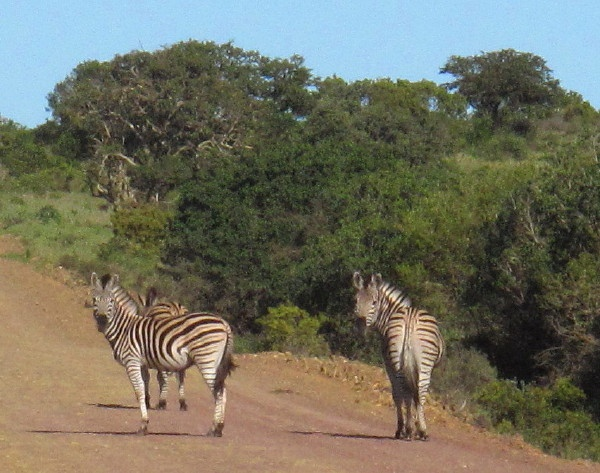Describe the objects in this image and their specific colors. I can see zebra in lightblue, maroon, gray, and tan tones, zebra in lightblue, gray, and black tones, and zebra in lightblue, tan, gray, and maroon tones in this image. 